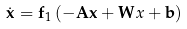Convert formula to latex. <formula><loc_0><loc_0><loc_500><loc_500>\dot { \mathbf x } = { \mathbf f } _ { 1 } \left ( - { \mathbf A } { \mathbf x } + { \mathbf W } x + { \mathbf b } \right )</formula> 